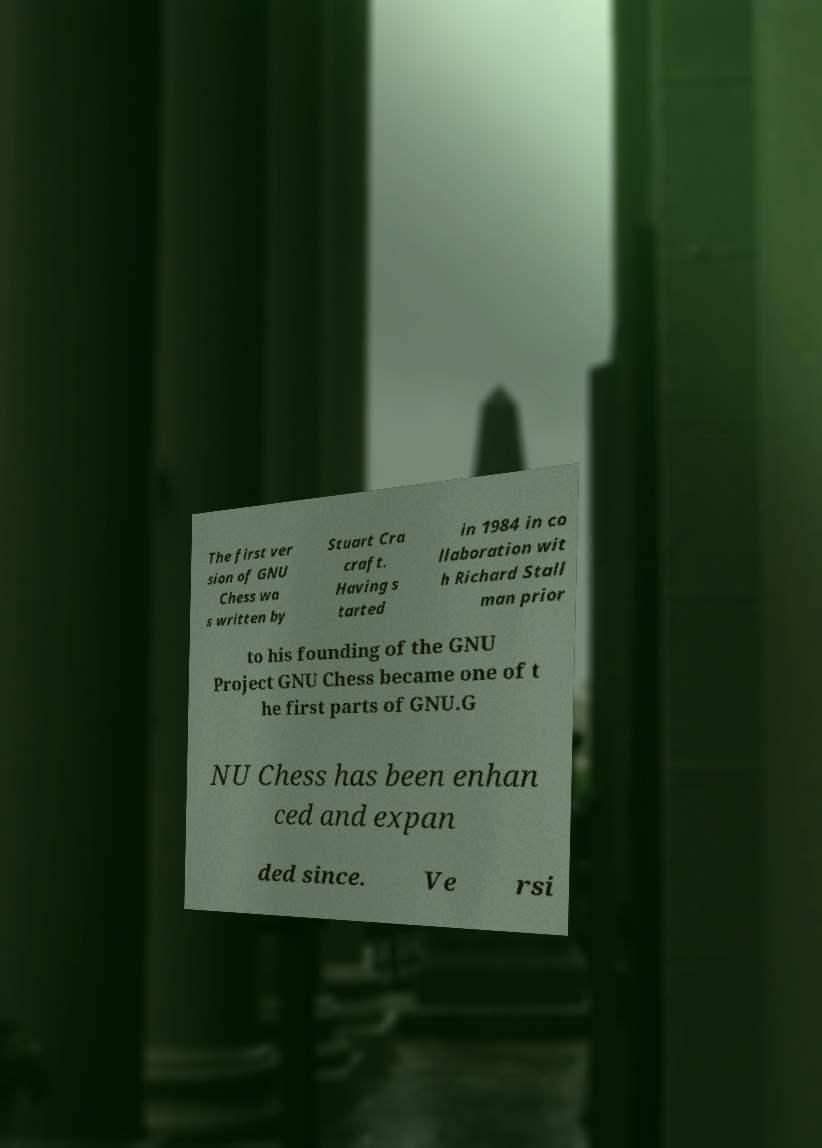There's text embedded in this image that I need extracted. Can you transcribe it verbatim? The first ver sion of GNU Chess wa s written by Stuart Cra craft. Having s tarted in 1984 in co llaboration wit h Richard Stall man prior to his founding of the GNU Project GNU Chess became one of t he first parts of GNU.G NU Chess has been enhan ced and expan ded since. Ve rsi 